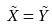Convert formula to latex. <formula><loc_0><loc_0><loc_500><loc_500>\tilde { X } = \tilde { Y }</formula> 